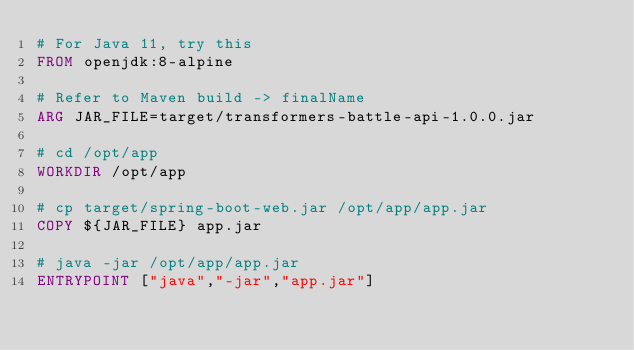Convert code to text. <code><loc_0><loc_0><loc_500><loc_500><_Dockerfile_># For Java 11, try this
FROM openjdk:8-alpine

# Refer to Maven build -> finalName
ARG JAR_FILE=target/transformers-battle-api-1.0.0.jar

# cd /opt/app
WORKDIR /opt/app

# cp target/spring-boot-web.jar /opt/app/app.jar
COPY ${JAR_FILE} app.jar

# java -jar /opt/app/app.jar
ENTRYPOINT ["java","-jar","app.jar"]</code> 